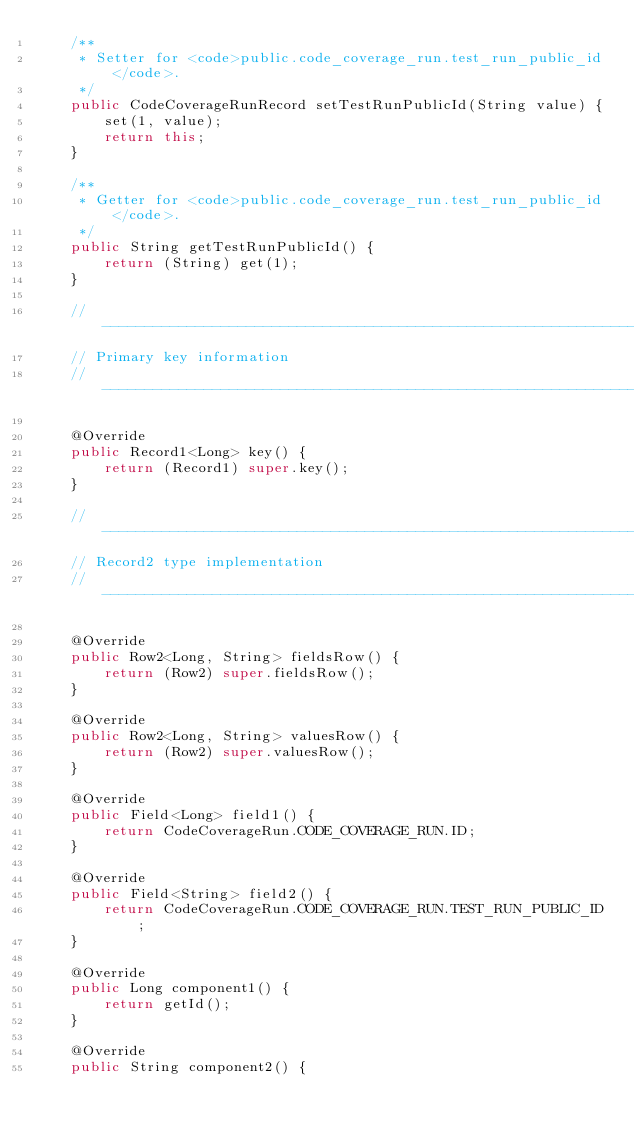<code> <loc_0><loc_0><loc_500><loc_500><_Java_>    /**
     * Setter for <code>public.code_coverage_run.test_run_public_id</code>.
     */
    public CodeCoverageRunRecord setTestRunPublicId(String value) {
        set(1, value);
        return this;
    }

    /**
     * Getter for <code>public.code_coverage_run.test_run_public_id</code>.
     */
    public String getTestRunPublicId() {
        return (String) get(1);
    }

    // -------------------------------------------------------------------------
    // Primary key information
    // -------------------------------------------------------------------------

    @Override
    public Record1<Long> key() {
        return (Record1) super.key();
    }

    // -------------------------------------------------------------------------
    // Record2 type implementation
    // -------------------------------------------------------------------------

    @Override
    public Row2<Long, String> fieldsRow() {
        return (Row2) super.fieldsRow();
    }

    @Override
    public Row2<Long, String> valuesRow() {
        return (Row2) super.valuesRow();
    }

    @Override
    public Field<Long> field1() {
        return CodeCoverageRun.CODE_COVERAGE_RUN.ID;
    }

    @Override
    public Field<String> field2() {
        return CodeCoverageRun.CODE_COVERAGE_RUN.TEST_RUN_PUBLIC_ID;
    }

    @Override
    public Long component1() {
        return getId();
    }

    @Override
    public String component2() {</code> 